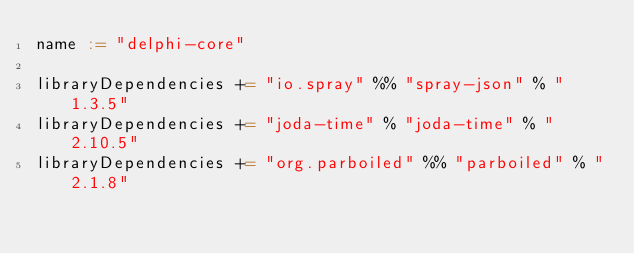Convert code to text. <code><loc_0><loc_0><loc_500><loc_500><_Scala_>name := "delphi-core"

libraryDependencies += "io.spray" %% "spray-json" % "1.3.5"
libraryDependencies += "joda-time" % "joda-time" % "2.10.5"
libraryDependencies += "org.parboiled" %% "parboiled" % "2.1.8"
</code> 